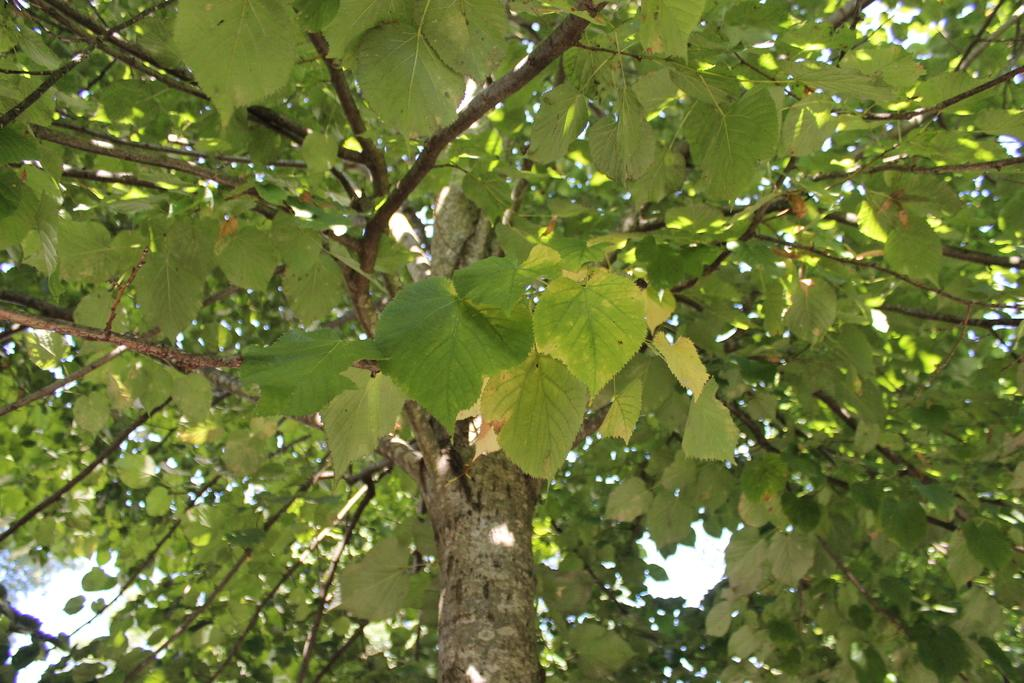What type of plant is present in the image? There is a tree with green leaves in the image. What can be seen in the background of the image? There is a sky visible in the background of the image. What type of pump is used to water the tree in the image? There is no pump present in the image; it is a tree with green leaves and a sky visible in the background. 